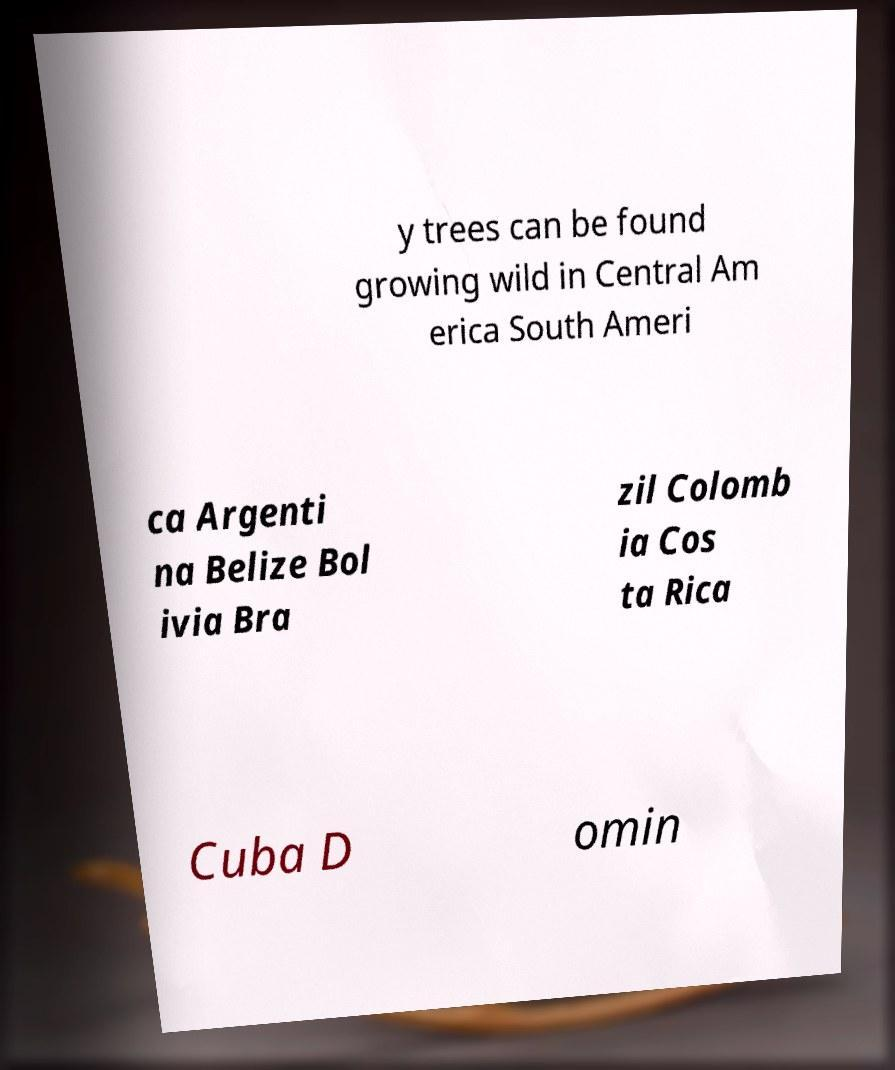For documentation purposes, I need the text within this image transcribed. Could you provide that? y trees can be found growing wild in Central Am erica South Ameri ca Argenti na Belize Bol ivia Bra zil Colomb ia Cos ta Rica Cuba D omin 